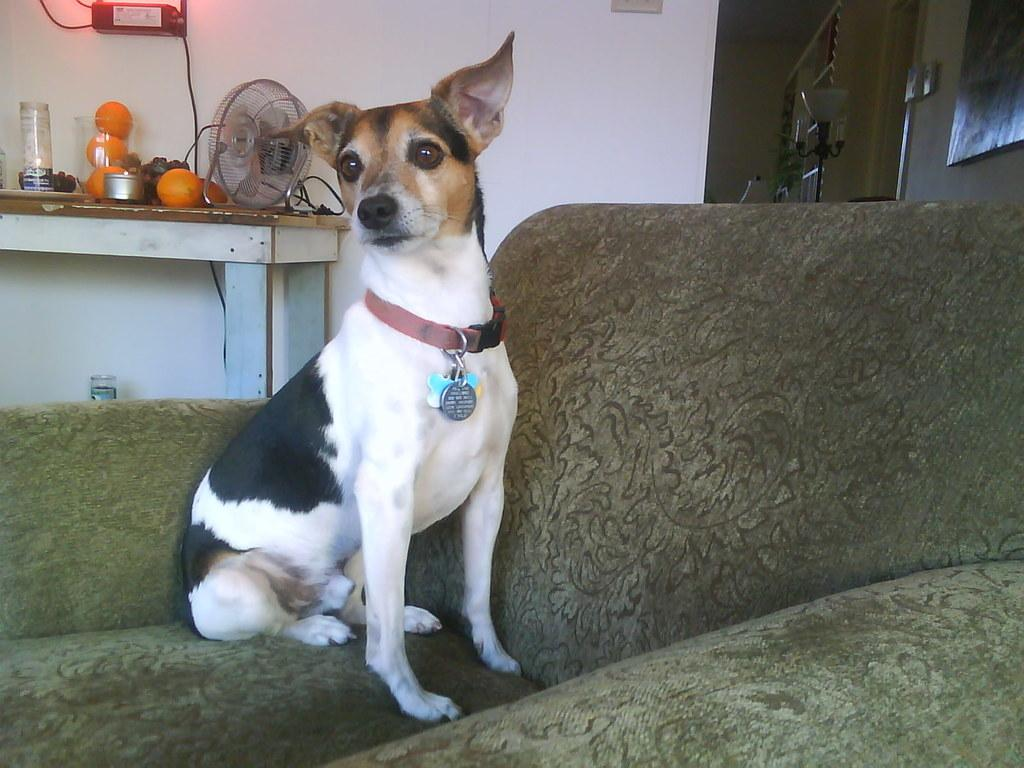What is the dog doing in the image? The dog is sitting on the sofa. What can be seen in the background of the image? There is a table in the background. What is on the table? There are oranges and a small fan on the table. What is visible on the wall in the image? There is a wall visible in the image. What are the dog's hobbies, as depicted in the image? The image does not provide information about the dog's hobbies. Is there a deer visible in the image? No, there is no deer present in the image. 